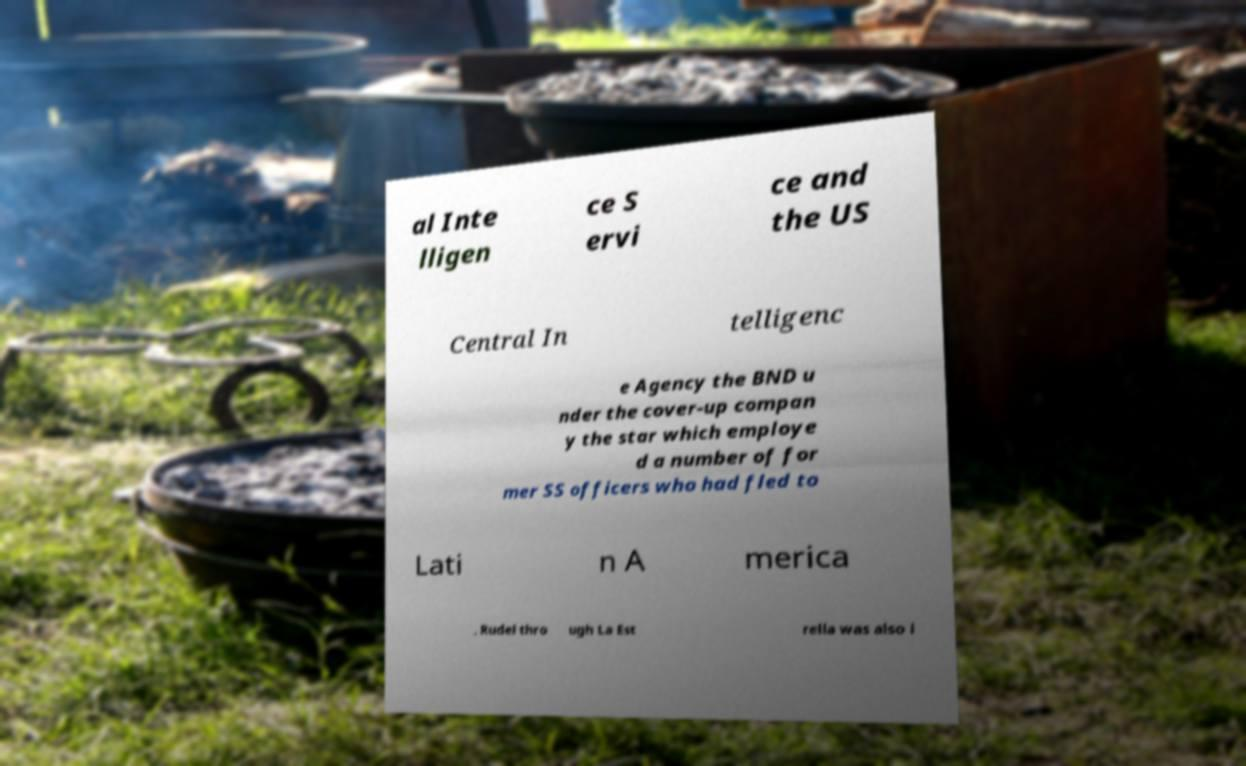What messages or text are displayed in this image? I need them in a readable, typed format. al Inte lligen ce S ervi ce and the US Central In telligenc e Agency the BND u nder the cover-up compan y the star which employe d a number of for mer SS officers who had fled to Lati n A merica . Rudel thro ugh La Est rella was also i 